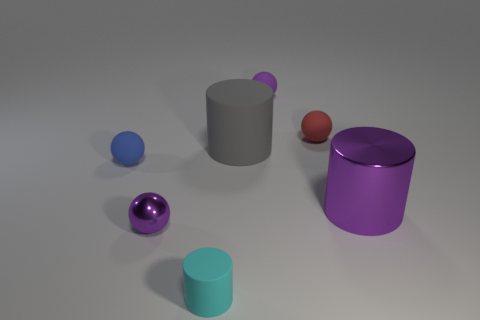Subtract 1 balls. How many balls are left? 3 Add 2 tiny spheres. How many objects exist? 9 Subtract 1 purple cylinders. How many objects are left? 6 Subtract all cylinders. How many objects are left? 4 Subtract all small blue matte objects. Subtract all large cyan spheres. How many objects are left? 6 Add 3 small rubber balls. How many small rubber balls are left? 6 Add 5 big brown shiny things. How many big brown shiny things exist? 5 